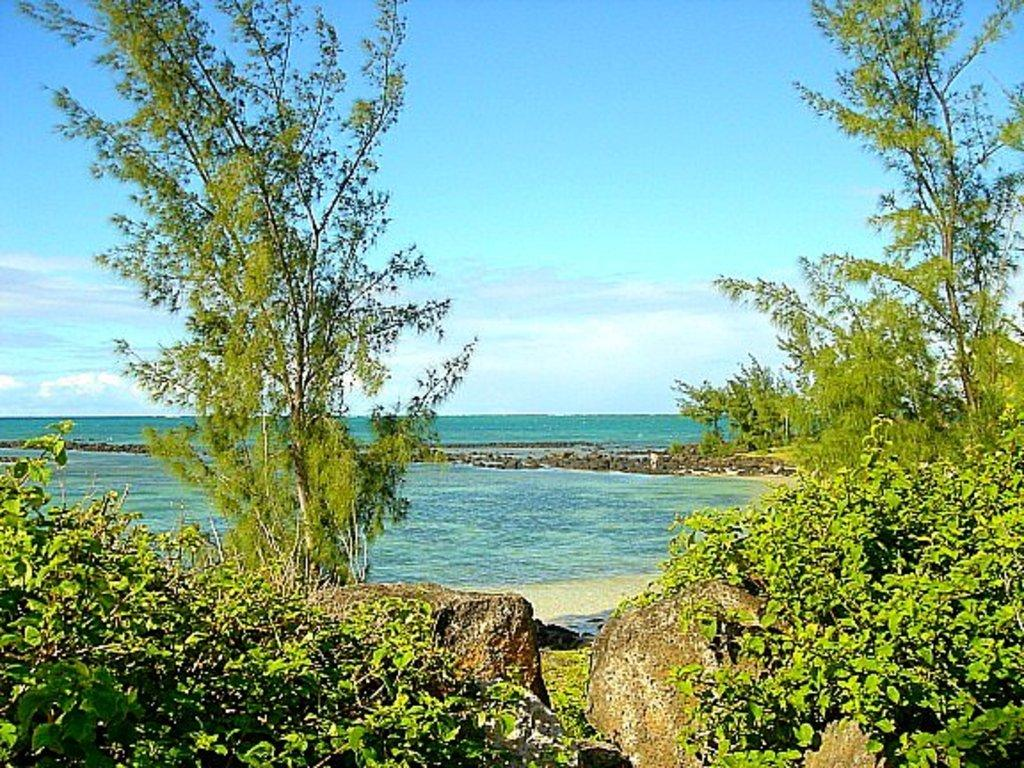What can be seen in the foreground of the picture? In the foreground of the picture, there are plants, trees, and rocks. What is located in the middle of the picture? In the middle of the picture, there is a water body, a rock, and sand. What is visible in the background of the picture? The sky is visible in the background of the picture. How many blades are visible in the picture? There are no blades present in the picture. What type of cloud can be seen in the picture? There are no clouds visible in the picture; only the sky is visible in the background. 